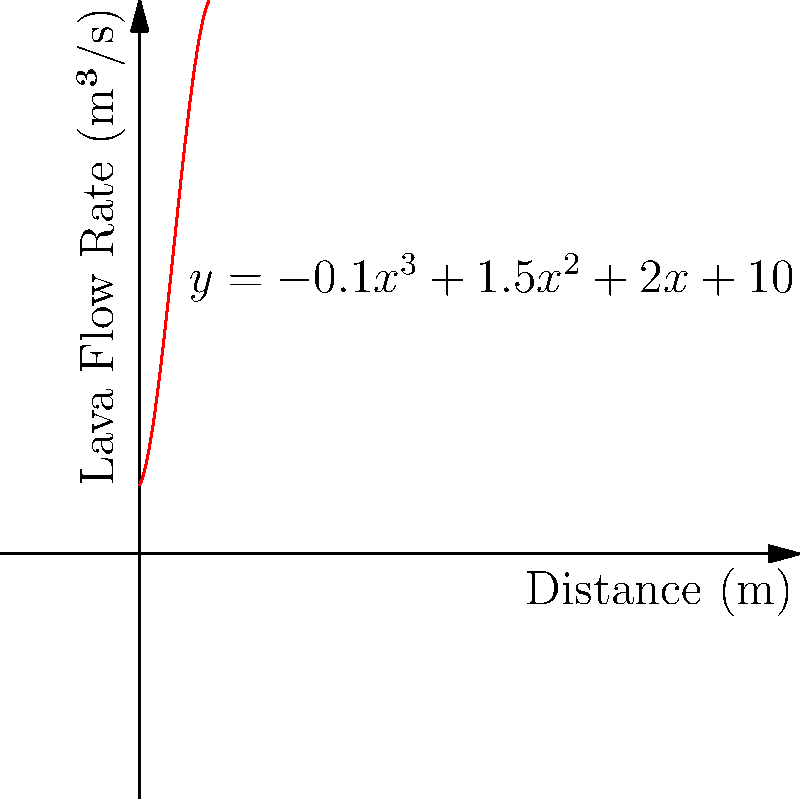The rate of lava flow down a volcanic slope is represented by the polynomial equation $y = -0.1x^3 + 1.5x^2 + 2x + 10$, where $y$ is the flow rate in cubic meters per second and $x$ is the distance from the crater in meters. At what distance from the crater does the lava flow reach its maximum rate? To find the maximum flow rate, we need to follow these steps:

1) The maximum point occurs where the derivative of the function is zero. Let's find the derivative:

   $\frac{dy}{dx} = -0.3x^2 + 3x + 2$

2) Set the derivative equal to zero and solve for x:

   $-0.3x^2 + 3x + 2 = 0$

3) This is a quadratic equation. We can solve it using the quadratic formula:
   $x = \frac{-b \pm \sqrt{b^2 - 4ac}}{2a}$

   Where $a = -0.3$, $b = 3$, and $c = 2$

4) Plugging these values into the quadratic formula:

   $x = \frac{-3 \pm \sqrt{3^2 - 4(-0.3)(2)}}{2(-0.3)}$

5) Simplifying:

   $x = \frac{-3 \pm \sqrt{9 + 2.4}}{-0.6} = \frac{-3 \pm \sqrt{11.4}}{-0.6}$

6) This gives us two solutions:

   $x \approx 5.88$ or $x \approx 1.12$

7) To determine which of these is the maximum (rather than the minimum), we can check the second derivative:

   $\frac{d^2y}{dx^2} = -0.6x + 3$

8) At $x = 5.88$, the second derivative is negative, indicating this is the maximum point.

Therefore, the lava flow reaches its maximum rate approximately 5.88 meters from the crater.
Answer: 5.88 meters 